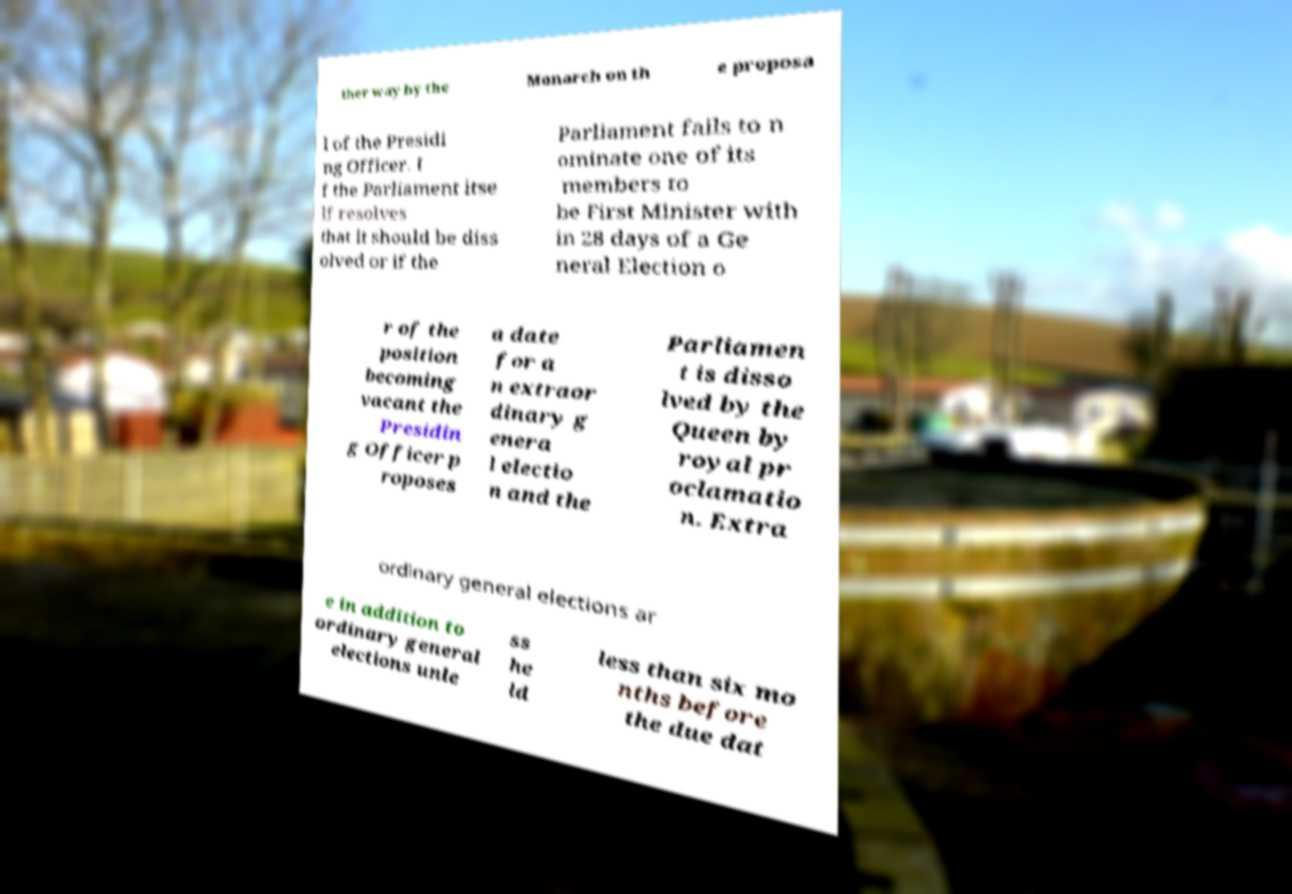I need the written content from this picture converted into text. Can you do that? ther way by the Monarch on th e proposa l of the Presidi ng Officer. I f the Parliament itse lf resolves that it should be diss olved or if the Parliament fails to n ominate one of its members to be First Minister with in 28 days of a Ge neral Election o r of the position becoming vacant the Presidin g Officer p roposes a date for a n extraor dinary g enera l electio n and the Parliamen t is disso lved by the Queen by royal pr oclamatio n. Extra ordinary general elections ar e in addition to ordinary general elections unle ss he ld less than six mo nths before the due dat 